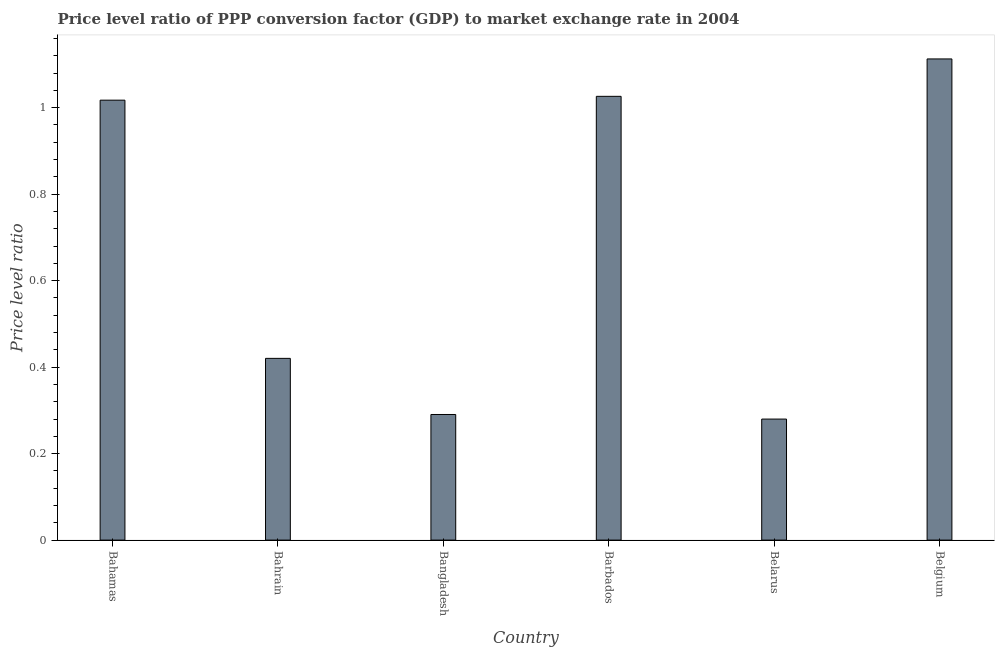What is the title of the graph?
Ensure brevity in your answer.  Price level ratio of PPP conversion factor (GDP) to market exchange rate in 2004. What is the label or title of the X-axis?
Ensure brevity in your answer.  Country. What is the label or title of the Y-axis?
Your response must be concise. Price level ratio. What is the price level ratio in Bahrain?
Give a very brief answer. 0.42. Across all countries, what is the maximum price level ratio?
Make the answer very short. 1.11. Across all countries, what is the minimum price level ratio?
Offer a very short reply. 0.28. In which country was the price level ratio minimum?
Your response must be concise. Belarus. What is the sum of the price level ratio?
Offer a terse response. 4.15. What is the difference between the price level ratio in Bahamas and Bahrain?
Your response must be concise. 0.6. What is the average price level ratio per country?
Offer a terse response. 0.69. What is the median price level ratio?
Offer a terse response. 0.72. In how many countries, is the price level ratio greater than 0.28 ?
Make the answer very short. 5. What is the ratio of the price level ratio in Bahamas to that in Bangladesh?
Keep it short and to the point. 3.5. What is the difference between the highest and the second highest price level ratio?
Keep it short and to the point. 0.09. Is the sum of the price level ratio in Barbados and Belarus greater than the maximum price level ratio across all countries?
Your answer should be very brief. Yes. What is the difference between the highest and the lowest price level ratio?
Offer a very short reply. 0.83. In how many countries, is the price level ratio greater than the average price level ratio taken over all countries?
Provide a succinct answer. 3. How many bars are there?
Keep it short and to the point. 6. How many countries are there in the graph?
Offer a terse response. 6. What is the difference between two consecutive major ticks on the Y-axis?
Your answer should be very brief. 0.2. What is the Price level ratio in Bahamas?
Give a very brief answer. 1.02. What is the Price level ratio in Bahrain?
Offer a very short reply. 0.42. What is the Price level ratio in Bangladesh?
Offer a terse response. 0.29. What is the Price level ratio in Barbados?
Your answer should be compact. 1.03. What is the Price level ratio of Belarus?
Make the answer very short. 0.28. What is the Price level ratio in Belgium?
Offer a very short reply. 1.11. What is the difference between the Price level ratio in Bahamas and Bahrain?
Keep it short and to the point. 0.6. What is the difference between the Price level ratio in Bahamas and Bangladesh?
Your answer should be compact. 0.73. What is the difference between the Price level ratio in Bahamas and Barbados?
Ensure brevity in your answer.  -0.01. What is the difference between the Price level ratio in Bahamas and Belarus?
Give a very brief answer. 0.74. What is the difference between the Price level ratio in Bahamas and Belgium?
Ensure brevity in your answer.  -0.1. What is the difference between the Price level ratio in Bahrain and Bangladesh?
Your answer should be compact. 0.13. What is the difference between the Price level ratio in Bahrain and Barbados?
Your answer should be very brief. -0.61. What is the difference between the Price level ratio in Bahrain and Belarus?
Make the answer very short. 0.14. What is the difference between the Price level ratio in Bahrain and Belgium?
Your answer should be very brief. -0.69. What is the difference between the Price level ratio in Bangladesh and Barbados?
Offer a terse response. -0.74. What is the difference between the Price level ratio in Bangladesh and Belarus?
Make the answer very short. 0.01. What is the difference between the Price level ratio in Bangladesh and Belgium?
Make the answer very short. -0.82. What is the difference between the Price level ratio in Barbados and Belarus?
Give a very brief answer. 0.75. What is the difference between the Price level ratio in Barbados and Belgium?
Offer a terse response. -0.09. What is the difference between the Price level ratio in Belarus and Belgium?
Provide a succinct answer. -0.83. What is the ratio of the Price level ratio in Bahamas to that in Bahrain?
Keep it short and to the point. 2.42. What is the ratio of the Price level ratio in Bahamas to that in Bangladesh?
Provide a short and direct response. 3.5. What is the ratio of the Price level ratio in Bahamas to that in Barbados?
Offer a terse response. 0.99. What is the ratio of the Price level ratio in Bahamas to that in Belarus?
Provide a short and direct response. 3.63. What is the ratio of the Price level ratio in Bahamas to that in Belgium?
Make the answer very short. 0.91. What is the ratio of the Price level ratio in Bahrain to that in Bangladesh?
Keep it short and to the point. 1.45. What is the ratio of the Price level ratio in Bahrain to that in Barbados?
Provide a succinct answer. 0.41. What is the ratio of the Price level ratio in Bahrain to that in Belarus?
Make the answer very short. 1.5. What is the ratio of the Price level ratio in Bahrain to that in Belgium?
Your response must be concise. 0.38. What is the ratio of the Price level ratio in Bangladesh to that in Barbados?
Your answer should be compact. 0.28. What is the ratio of the Price level ratio in Bangladesh to that in Belarus?
Offer a terse response. 1.04. What is the ratio of the Price level ratio in Bangladesh to that in Belgium?
Keep it short and to the point. 0.26. What is the ratio of the Price level ratio in Barbados to that in Belarus?
Give a very brief answer. 3.67. What is the ratio of the Price level ratio in Barbados to that in Belgium?
Offer a very short reply. 0.92. What is the ratio of the Price level ratio in Belarus to that in Belgium?
Your answer should be very brief. 0.25. 